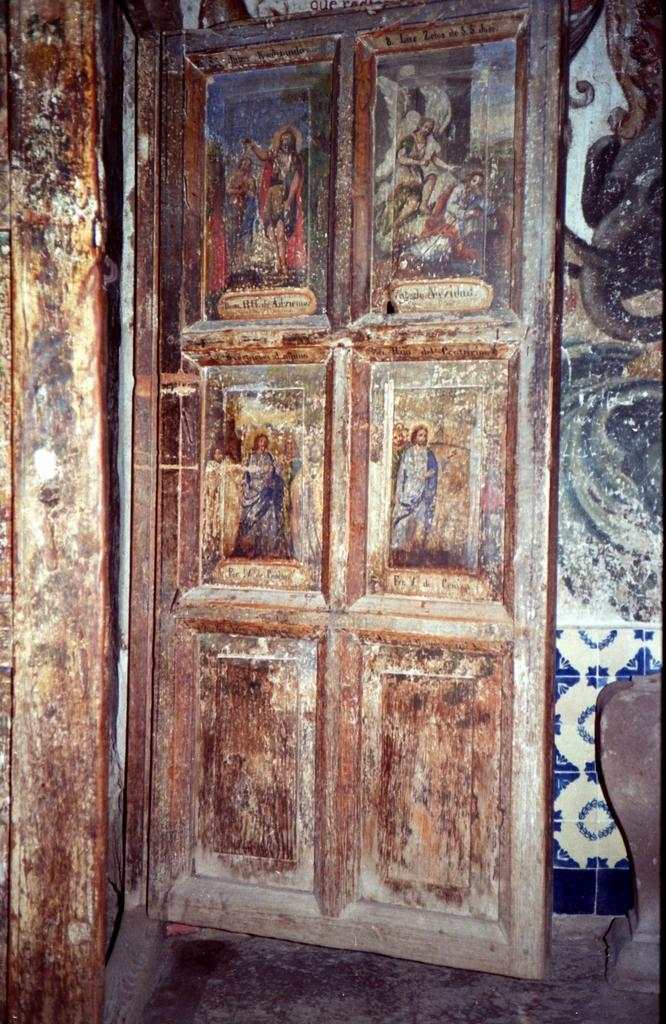What is one of the main structures visible in the image? There is a door in the image. What is the door attached to? The door is attached to a wall, which is also visible in the image. What decorative elements can be seen on the door? Pictures are present on the door. What type of rod can be seen holding up the pictures on the door? There is no rod visible in the image; the pictures are simply attached to the door. 